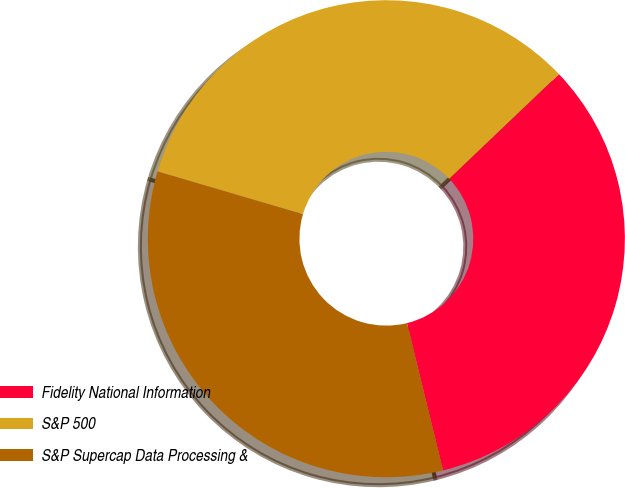Convert chart. <chart><loc_0><loc_0><loc_500><loc_500><pie_chart><fcel>Fidelity National Information<fcel>S&P 500<fcel>S&P Supercap Data Processing &<nl><fcel>33.3%<fcel>33.33%<fcel>33.37%<nl></chart> 